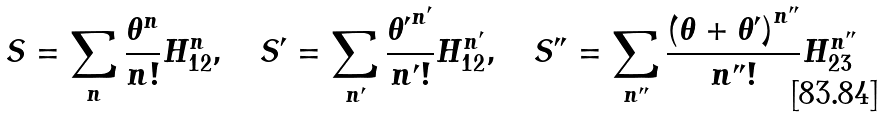<formula> <loc_0><loc_0><loc_500><loc_500>S = \sum _ { n } \frac { { \theta } ^ { n } } { n ! } H _ { 1 2 } ^ { n } , \quad S ^ { \prime } = \sum _ { n ^ { \prime } } \frac { { \theta ^ { \prime } } ^ { n ^ { \prime } } } { n ^ { \prime } ! } H _ { 1 2 } ^ { n ^ { \prime } } , \quad S ^ { \prime \prime } = \sum _ { n ^ { \prime \prime } } \frac { { ( \theta + \theta ^ { \prime } ) } ^ { n ^ { \prime \prime } } } { n ^ { \prime \prime } ! } H _ { 2 3 } ^ { n ^ { \prime \prime } }</formula> 